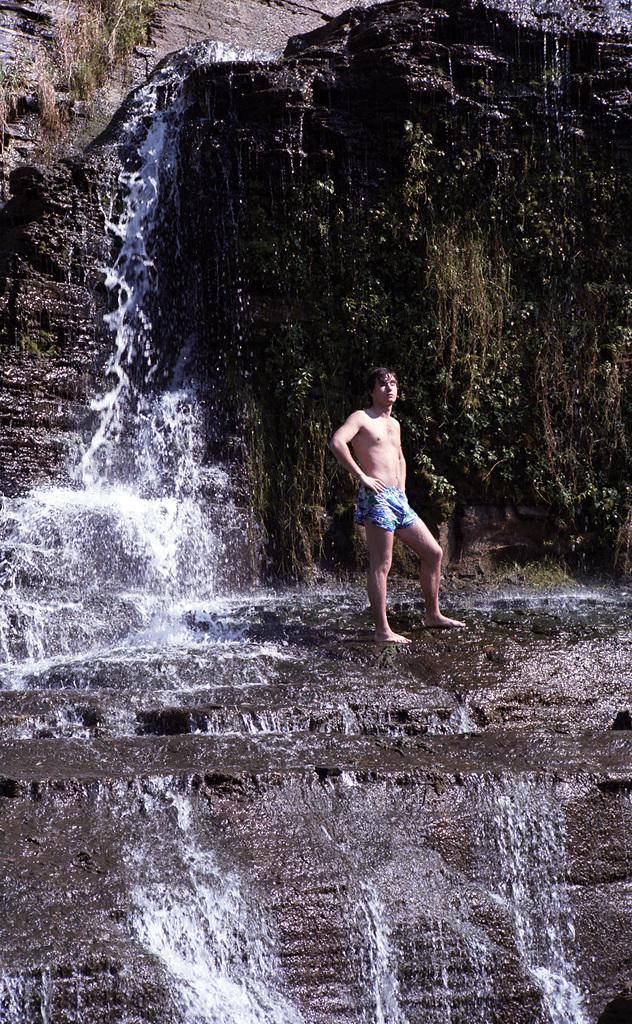What natural feature is the main subject of the image? There is a waterfall in the image. Can you describe the person's position in the image? There is a person standing on a rock in the image. What type of vegetation can be seen behind the person? There are plants visible behind the person. What landscape feature is visible in the background of the image? There is a hill visible in the background of the image. What type of jewel is the person wearing around their neck in the image? There is no jewel visible around the person's neck in the image. What type of home can be seen in the background of the image? There is no home visible in the background of the image; it features a hill instead. 